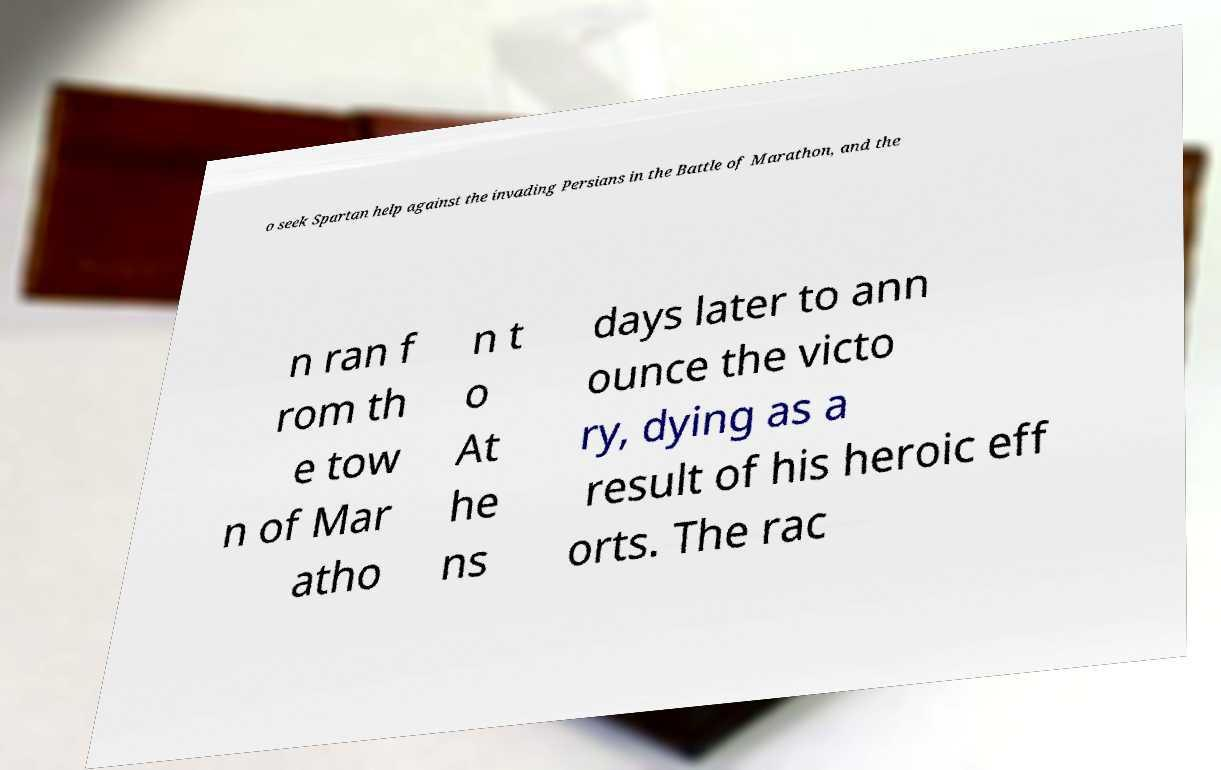Could you extract and type out the text from this image? o seek Spartan help against the invading Persians in the Battle of Marathon, and the n ran f rom th e tow n of Mar atho n t o At he ns days later to ann ounce the victo ry, dying as a result of his heroic eff orts. The rac 